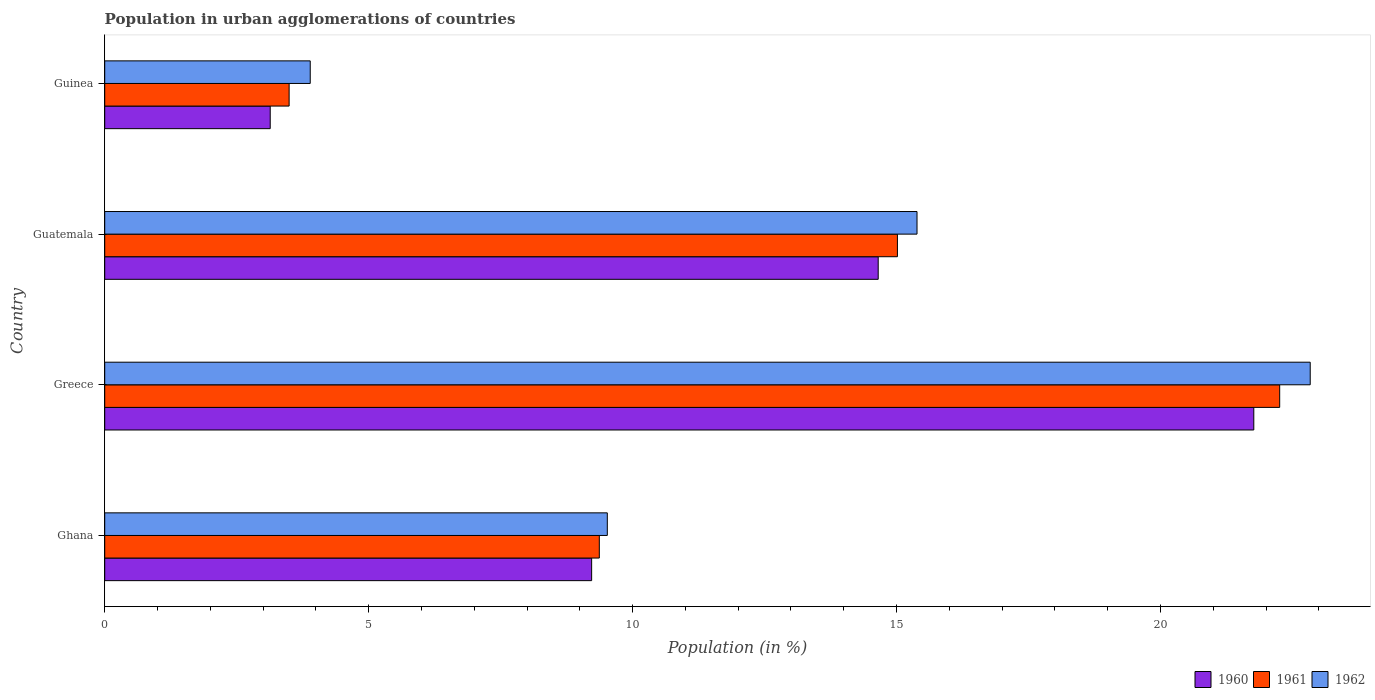Are the number of bars on each tick of the Y-axis equal?
Provide a succinct answer. Yes. How many bars are there on the 2nd tick from the bottom?
Your answer should be very brief. 3. In how many cases, is the number of bars for a given country not equal to the number of legend labels?
Your answer should be very brief. 0. What is the percentage of population in urban agglomerations in 1962 in Greece?
Give a very brief answer. 22.84. Across all countries, what is the maximum percentage of population in urban agglomerations in 1960?
Your answer should be compact. 21.77. Across all countries, what is the minimum percentage of population in urban agglomerations in 1962?
Your response must be concise. 3.89. In which country was the percentage of population in urban agglomerations in 1961 minimum?
Give a very brief answer. Guinea. What is the total percentage of population in urban agglomerations in 1962 in the graph?
Offer a very short reply. 51.64. What is the difference between the percentage of population in urban agglomerations in 1962 in Guatemala and that in Guinea?
Keep it short and to the point. 11.49. What is the difference between the percentage of population in urban agglomerations in 1961 in Greece and the percentage of population in urban agglomerations in 1960 in Guinea?
Ensure brevity in your answer.  19.12. What is the average percentage of population in urban agglomerations in 1961 per country?
Provide a succinct answer. 12.53. What is the difference between the percentage of population in urban agglomerations in 1960 and percentage of population in urban agglomerations in 1961 in Guinea?
Offer a terse response. -0.36. What is the ratio of the percentage of population in urban agglomerations in 1962 in Ghana to that in Guinea?
Keep it short and to the point. 2.45. Is the percentage of population in urban agglomerations in 1962 in Ghana less than that in Guatemala?
Offer a terse response. Yes. What is the difference between the highest and the second highest percentage of population in urban agglomerations in 1962?
Offer a terse response. 7.45. What is the difference between the highest and the lowest percentage of population in urban agglomerations in 1961?
Your answer should be very brief. 18.77. What does the 3rd bar from the top in Guatemala represents?
Your answer should be compact. 1960. What does the 1st bar from the bottom in Guinea represents?
Make the answer very short. 1960. What is the difference between two consecutive major ticks on the X-axis?
Provide a short and direct response. 5. Does the graph contain any zero values?
Offer a terse response. No. How are the legend labels stacked?
Provide a short and direct response. Horizontal. What is the title of the graph?
Ensure brevity in your answer.  Population in urban agglomerations of countries. What is the label or title of the X-axis?
Your answer should be compact. Population (in %). What is the Population (in %) in 1960 in Ghana?
Provide a succinct answer. 9.22. What is the Population (in %) in 1961 in Ghana?
Your response must be concise. 9.37. What is the Population (in %) of 1962 in Ghana?
Your response must be concise. 9.52. What is the Population (in %) of 1960 in Greece?
Keep it short and to the point. 21.77. What is the Population (in %) in 1961 in Greece?
Ensure brevity in your answer.  22.26. What is the Population (in %) in 1962 in Greece?
Your response must be concise. 22.84. What is the Population (in %) of 1960 in Guatemala?
Provide a succinct answer. 14.65. What is the Population (in %) of 1961 in Guatemala?
Provide a short and direct response. 15.02. What is the Population (in %) of 1962 in Guatemala?
Your response must be concise. 15.39. What is the Population (in %) in 1960 in Guinea?
Provide a succinct answer. 3.14. What is the Population (in %) in 1961 in Guinea?
Your response must be concise. 3.49. What is the Population (in %) of 1962 in Guinea?
Your answer should be compact. 3.89. Across all countries, what is the maximum Population (in %) of 1960?
Your answer should be very brief. 21.77. Across all countries, what is the maximum Population (in %) in 1961?
Give a very brief answer. 22.26. Across all countries, what is the maximum Population (in %) of 1962?
Your answer should be compact. 22.84. Across all countries, what is the minimum Population (in %) of 1960?
Keep it short and to the point. 3.14. Across all countries, what is the minimum Population (in %) of 1961?
Your answer should be very brief. 3.49. Across all countries, what is the minimum Population (in %) in 1962?
Offer a very short reply. 3.89. What is the total Population (in %) in 1960 in the graph?
Provide a short and direct response. 48.78. What is the total Population (in %) of 1961 in the graph?
Give a very brief answer. 50.14. What is the total Population (in %) in 1962 in the graph?
Your response must be concise. 51.64. What is the difference between the Population (in %) in 1960 in Ghana and that in Greece?
Offer a very short reply. -12.54. What is the difference between the Population (in %) in 1961 in Ghana and that in Greece?
Make the answer very short. -12.89. What is the difference between the Population (in %) in 1962 in Ghana and that in Greece?
Keep it short and to the point. -13.32. What is the difference between the Population (in %) of 1960 in Ghana and that in Guatemala?
Your answer should be very brief. -5.43. What is the difference between the Population (in %) of 1961 in Ghana and that in Guatemala?
Ensure brevity in your answer.  -5.65. What is the difference between the Population (in %) in 1962 in Ghana and that in Guatemala?
Your answer should be compact. -5.87. What is the difference between the Population (in %) in 1960 in Ghana and that in Guinea?
Provide a succinct answer. 6.09. What is the difference between the Population (in %) of 1961 in Ghana and that in Guinea?
Offer a very short reply. 5.88. What is the difference between the Population (in %) in 1962 in Ghana and that in Guinea?
Your response must be concise. 5.63. What is the difference between the Population (in %) in 1960 in Greece and that in Guatemala?
Make the answer very short. 7.12. What is the difference between the Population (in %) of 1961 in Greece and that in Guatemala?
Provide a short and direct response. 7.24. What is the difference between the Population (in %) of 1962 in Greece and that in Guatemala?
Make the answer very short. 7.45. What is the difference between the Population (in %) in 1960 in Greece and that in Guinea?
Your answer should be compact. 18.63. What is the difference between the Population (in %) in 1961 in Greece and that in Guinea?
Ensure brevity in your answer.  18.77. What is the difference between the Population (in %) of 1962 in Greece and that in Guinea?
Make the answer very short. 18.94. What is the difference between the Population (in %) in 1960 in Guatemala and that in Guinea?
Your answer should be compact. 11.52. What is the difference between the Population (in %) of 1961 in Guatemala and that in Guinea?
Your answer should be compact. 11.52. What is the difference between the Population (in %) of 1962 in Guatemala and that in Guinea?
Keep it short and to the point. 11.49. What is the difference between the Population (in %) of 1960 in Ghana and the Population (in %) of 1961 in Greece?
Provide a short and direct response. -13.03. What is the difference between the Population (in %) of 1960 in Ghana and the Population (in %) of 1962 in Greece?
Your response must be concise. -13.61. What is the difference between the Population (in %) of 1961 in Ghana and the Population (in %) of 1962 in Greece?
Offer a terse response. -13.47. What is the difference between the Population (in %) in 1960 in Ghana and the Population (in %) in 1961 in Guatemala?
Provide a short and direct response. -5.79. What is the difference between the Population (in %) in 1960 in Ghana and the Population (in %) in 1962 in Guatemala?
Your response must be concise. -6.16. What is the difference between the Population (in %) in 1961 in Ghana and the Population (in %) in 1962 in Guatemala?
Your answer should be compact. -6.02. What is the difference between the Population (in %) in 1960 in Ghana and the Population (in %) in 1961 in Guinea?
Your answer should be very brief. 5.73. What is the difference between the Population (in %) in 1960 in Ghana and the Population (in %) in 1962 in Guinea?
Make the answer very short. 5.33. What is the difference between the Population (in %) of 1961 in Ghana and the Population (in %) of 1962 in Guinea?
Make the answer very short. 5.48. What is the difference between the Population (in %) in 1960 in Greece and the Population (in %) in 1961 in Guatemala?
Keep it short and to the point. 6.75. What is the difference between the Population (in %) in 1960 in Greece and the Population (in %) in 1962 in Guatemala?
Your answer should be compact. 6.38. What is the difference between the Population (in %) of 1961 in Greece and the Population (in %) of 1962 in Guatemala?
Your answer should be compact. 6.87. What is the difference between the Population (in %) of 1960 in Greece and the Population (in %) of 1961 in Guinea?
Keep it short and to the point. 18.27. What is the difference between the Population (in %) in 1960 in Greece and the Population (in %) in 1962 in Guinea?
Offer a very short reply. 17.87. What is the difference between the Population (in %) of 1961 in Greece and the Population (in %) of 1962 in Guinea?
Provide a succinct answer. 18.37. What is the difference between the Population (in %) of 1960 in Guatemala and the Population (in %) of 1961 in Guinea?
Ensure brevity in your answer.  11.16. What is the difference between the Population (in %) in 1960 in Guatemala and the Population (in %) in 1962 in Guinea?
Keep it short and to the point. 10.76. What is the difference between the Population (in %) in 1961 in Guatemala and the Population (in %) in 1962 in Guinea?
Keep it short and to the point. 11.12. What is the average Population (in %) of 1960 per country?
Offer a terse response. 12.2. What is the average Population (in %) in 1961 per country?
Your answer should be compact. 12.53. What is the average Population (in %) of 1962 per country?
Make the answer very short. 12.91. What is the difference between the Population (in %) in 1960 and Population (in %) in 1961 in Ghana?
Offer a terse response. -0.15. What is the difference between the Population (in %) of 1960 and Population (in %) of 1962 in Ghana?
Your answer should be very brief. -0.3. What is the difference between the Population (in %) of 1961 and Population (in %) of 1962 in Ghana?
Make the answer very short. -0.15. What is the difference between the Population (in %) of 1960 and Population (in %) of 1961 in Greece?
Offer a very short reply. -0.49. What is the difference between the Population (in %) of 1960 and Population (in %) of 1962 in Greece?
Keep it short and to the point. -1.07. What is the difference between the Population (in %) of 1961 and Population (in %) of 1962 in Greece?
Offer a very short reply. -0.58. What is the difference between the Population (in %) of 1960 and Population (in %) of 1961 in Guatemala?
Offer a very short reply. -0.36. What is the difference between the Population (in %) of 1960 and Population (in %) of 1962 in Guatemala?
Make the answer very short. -0.74. What is the difference between the Population (in %) in 1961 and Population (in %) in 1962 in Guatemala?
Your response must be concise. -0.37. What is the difference between the Population (in %) of 1960 and Population (in %) of 1961 in Guinea?
Ensure brevity in your answer.  -0.36. What is the difference between the Population (in %) of 1960 and Population (in %) of 1962 in Guinea?
Your answer should be very brief. -0.76. What is the difference between the Population (in %) of 1961 and Population (in %) of 1962 in Guinea?
Your answer should be very brief. -0.4. What is the ratio of the Population (in %) of 1960 in Ghana to that in Greece?
Your answer should be very brief. 0.42. What is the ratio of the Population (in %) of 1961 in Ghana to that in Greece?
Ensure brevity in your answer.  0.42. What is the ratio of the Population (in %) of 1962 in Ghana to that in Greece?
Offer a terse response. 0.42. What is the ratio of the Population (in %) in 1960 in Ghana to that in Guatemala?
Your response must be concise. 0.63. What is the ratio of the Population (in %) in 1961 in Ghana to that in Guatemala?
Give a very brief answer. 0.62. What is the ratio of the Population (in %) of 1962 in Ghana to that in Guatemala?
Offer a very short reply. 0.62. What is the ratio of the Population (in %) of 1960 in Ghana to that in Guinea?
Ensure brevity in your answer.  2.94. What is the ratio of the Population (in %) in 1961 in Ghana to that in Guinea?
Provide a succinct answer. 2.68. What is the ratio of the Population (in %) of 1962 in Ghana to that in Guinea?
Your answer should be very brief. 2.45. What is the ratio of the Population (in %) of 1960 in Greece to that in Guatemala?
Your answer should be compact. 1.49. What is the ratio of the Population (in %) in 1961 in Greece to that in Guatemala?
Offer a terse response. 1.48. What is the ratio of the Population (in %) in 1962 in Greece to that in Guatemala?
Your response must be concise. 1.48. What is the ratio of the Population (in %) of 1960 in Greece to that in Guinea?
Provide a succinct answer. 6.94. What is the ratio of the Population (in %) of 1961 in Greece to that in Guinea?
Keep it short and to the point. 6.37. What is the ratio of the Population (in %) of 1962 in Greece to that in Guinea?
Provide a short and direct response. 5.87. What is the ratio of the Population (in %) in 1960 in Guatemala to that in Guinea?
Keep it short and to the point. 4.67. What is the ratio of the Population (in %) of 1961 in Guatemala to that in Guinea?
Ensure brevity in your answer.  4.3. What is the ratio of the Population (in %) of 1962 in Guatemala to that in Guinea?
Offer a very short reply. 3.95. What is the difference between the highest and the second highest Population (in %) in 1960?
Provide a succinct answer. 7.12. What is the difference between the highest and the second highest Population (in %) of 1961?
Your response must be concise. 7.24. What is the difference between the highest and the second highest Population (in %) in 1962?
Provide a succinct answer. 7.45. What is the difference between the highest and the lowest Population (in %) in 1960?
Offer a very short reply. 18.63. What is the difference between the highest and the lowest Population (in %) of 1961?
Provide a succinct answer. 18.77. What is the difference between the highest and the lowest Population (in %) of 1962?
Your answer should be very brief. 18.94. 